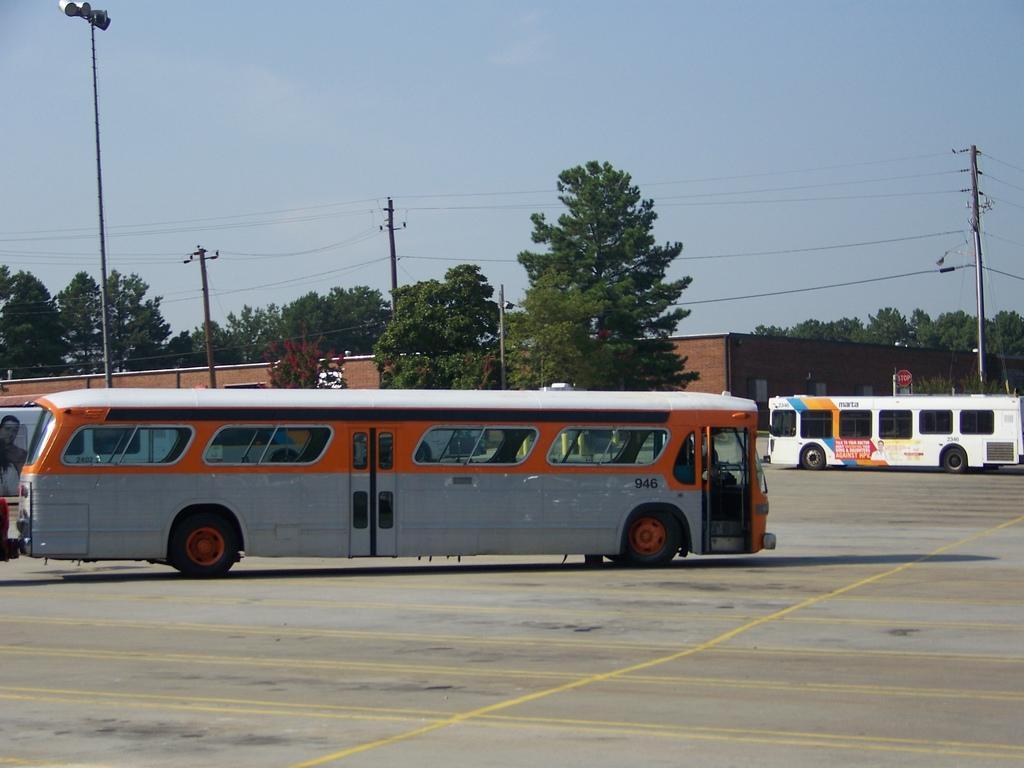In one or two sentences, can you explain what this image depicts? In this picture i can see many buses on the road. In the background i can see the building, electric poles, electric wires and many trees. At the top i can see the sky and clouds. On the right background there is a sign board near the fencing. 